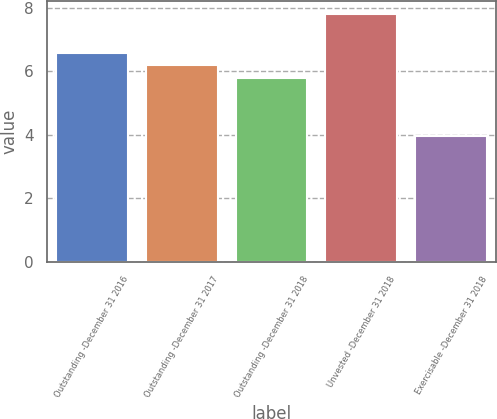Convert chart. <chart><loc_0><loc_0><loc_500><loc_500><bar_chart><fcel>Outstanding -December 31 2016<fcel>Outstanding -December 31 2017<fcel>Outstanding -December 31 2018<fcel>Unvested -December 31 2018<fcel>Exercisable -December 31 2018<nl><fcel>6.58<fcel>6.19<fcel>5.8<fcel>7.82<fcel>3.96<nl></chart> 